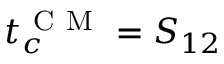Convert formula to latex. <formula><loc_0><loc_0><loc_500><loc_500>t _ { c } ^ { C M } = S _ { 1 2 }</formula> 